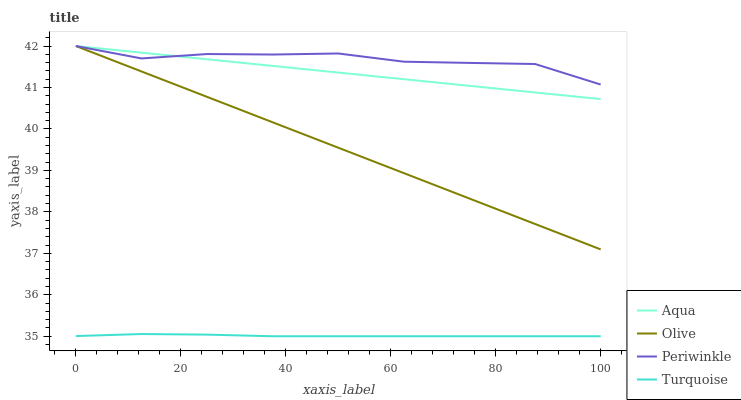Does Periwinkle have the minimum area under the curve?
Answer yes or no. No. Does Turquoise have the maximum area under the curve?
Answer yes or no. No. Is Turquoise the smoothest?
Answer yes or no. No. Is Turquoise the roughest?
Answer yes or no. No. Does Periwinkle have the lowest value?
Answer yes or no. No. Does Turquoise have the highest value?
Answer yes or no. No. Is Turquoise less than Olive?
Answer yes or no. Yes. Is Aqua greater than Turquoise?
Answer yes or no. Yes. Does Turquoise intersect Olive?
Answer yes or no. No. 